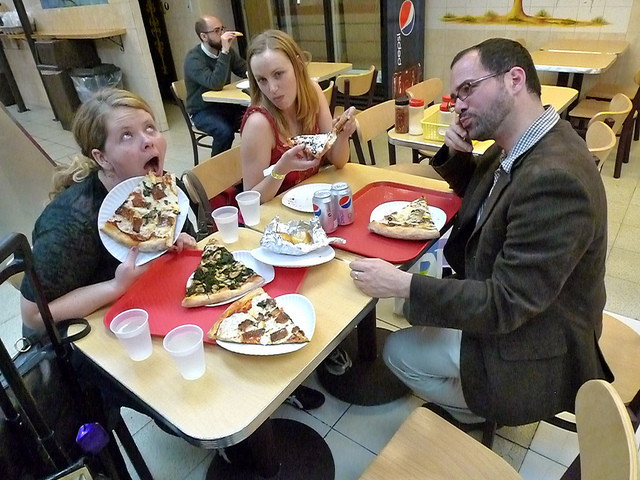What kind of pizzas are they having? One pizza appears topped with pepperoni and cheese, another with various greens indicating a possible vegetarian option, and the third features what looks like a combination of cheeses, a common choice for a cheese lover's pizza. 